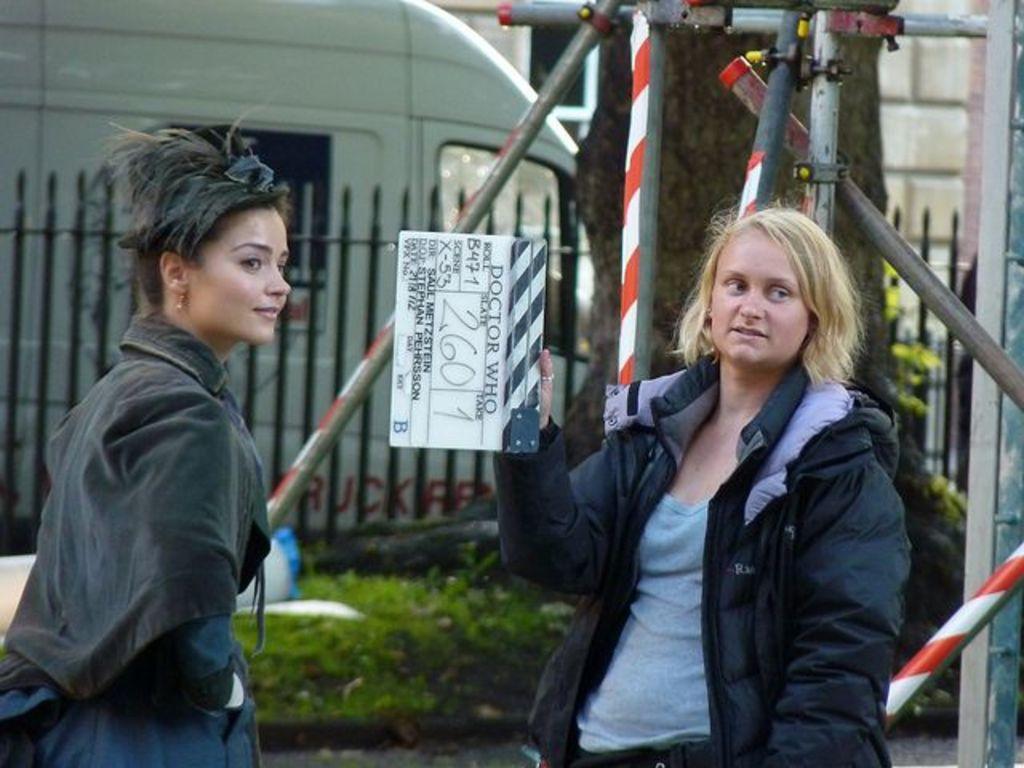Please provide a concise description of this image. In this picture we can see two women are standing in the front, a woman on the right side is holding a clapboard, in the background there is a wall, a vehicle and a window, we can see some plants, fencing and metal rods in the middle. 